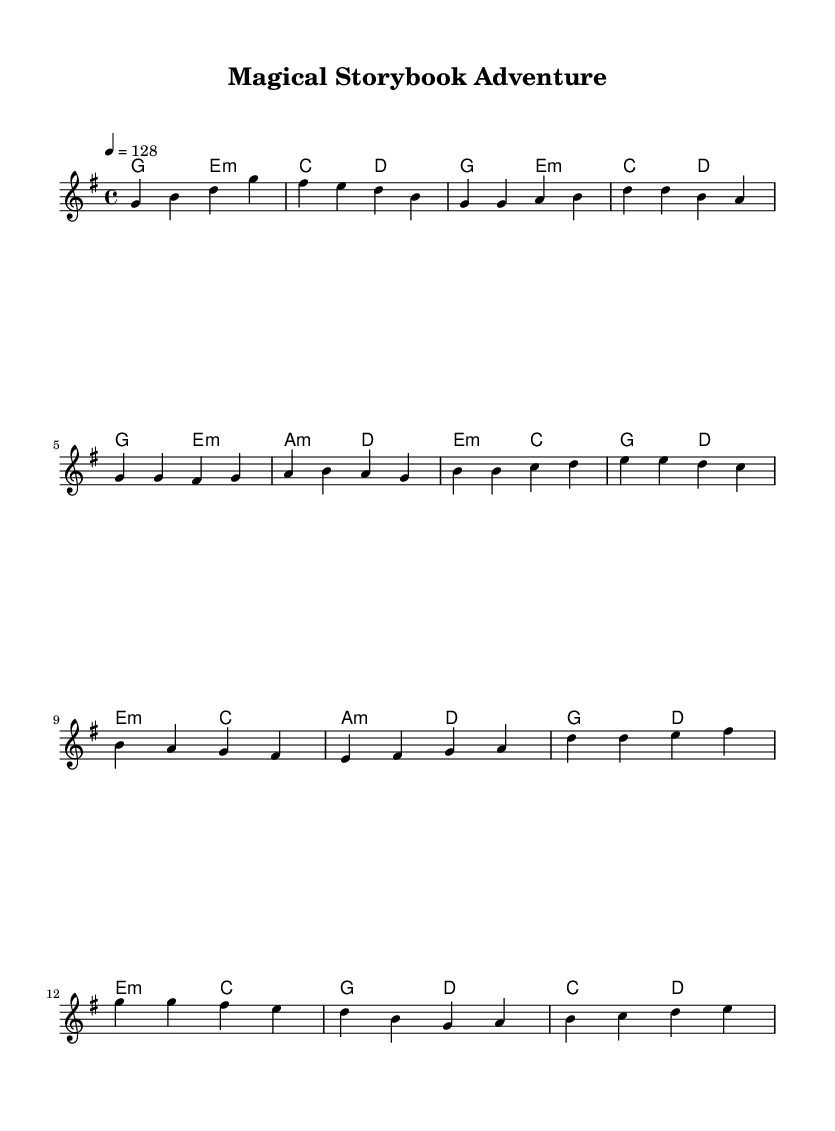What is the key signature of this music? The key signature is G major, which has one sharp (F#). You can identify this by looking at the beginning of the staff where the key signature is indicated.
Answer: G major What is the time signature of this music? The time signature is 4/4, which can be seen at the beginning of the score. It indicates that there are four beats in each measure.
Answer: 4/4 What is the tempo marking for this piece? The tempo marking indicates a speed of 128 beats per minute. This information is stated at the beginning of the score with '4 = 128'.
Answer: 128 How many measures are in the chorus section? The chorus section consists of 4 measures. By counting the individual measures in the chorus as indicated in the sheet music, you find there are four lines of music.
Answer: 4 Which type of chord is used in the pre-chorus? The pre-chorus primarily employs minor chords. By analyzing the chord symbols, you can see that there is a use of e minor and a minor chords.
Answer: Minor What is the structure of this piece? The structure is Intro, Verse, Pre-chorus, and Chorus. Observing the different sections of the piece, you can categorize them based on their purpose within the overall flow of the music.
Answer: Intro, Verse, Pre-chorus, Chorus What is the theme of this K-Pop track? The theme is magical storytelling and fantasy elements. This is inferred from the title "Magical Storybook Adventure" and the enchanting feel of the melody.
Answer: Magical storytelling 